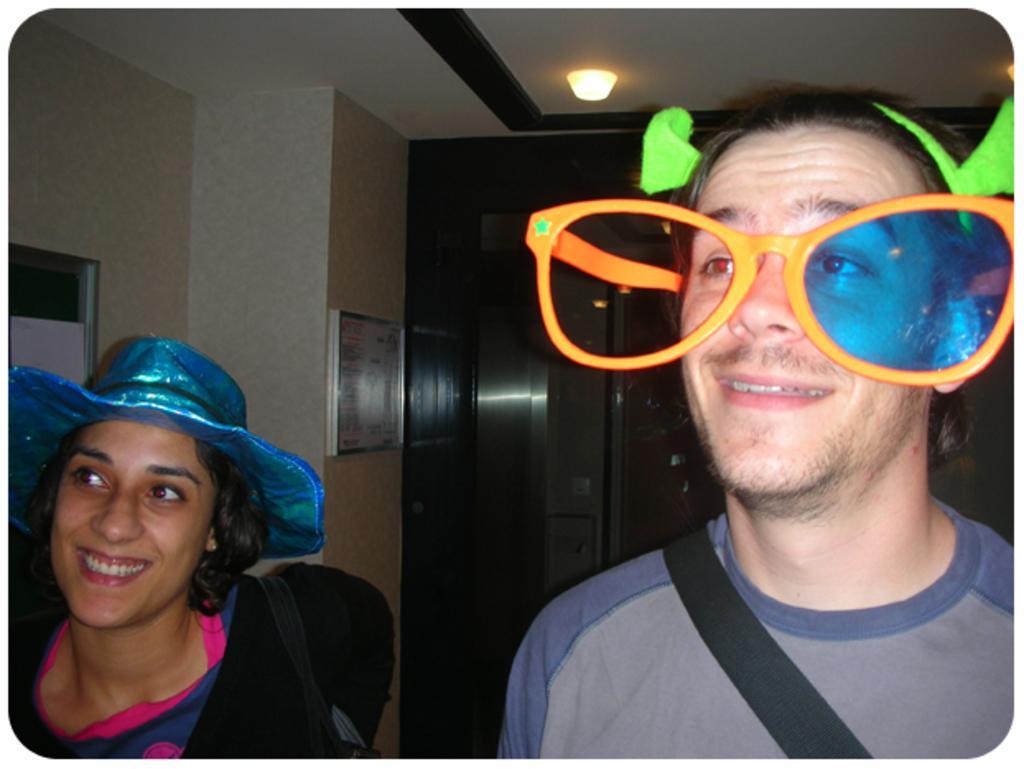Please provide a concise description of this image. In this image I can see two persons they both are smiling and on the right side person his wearing a spectacle, on the left side woman she wearing a cap and back side of them there is the wall and there is a notice board attached to the wall there is a light attached to the roof at the top. 